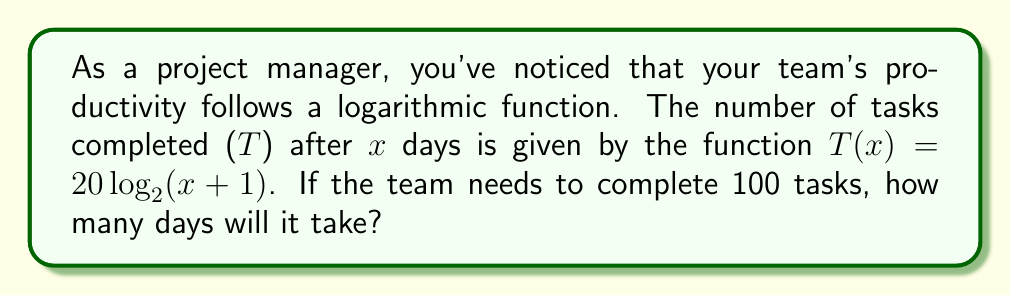Provide a solution to this math problem. 1) We need to solve the equation:
   $100 = 20 \log_2(x+1)$

2) Divide both sides by 20:
   $5 = \log_2(x+1)$

3) To solve for x, we need to apply the inverse function (exponential) to both sides:
   $2^5 = x+1$

4) Simplify the left side:
   $32 = x+1$

5) Subtract 1 from both sides:
   $31 = x$

Therefore, it will take 31 days for the team to complete 100 tasks.
Answer: 31 days 